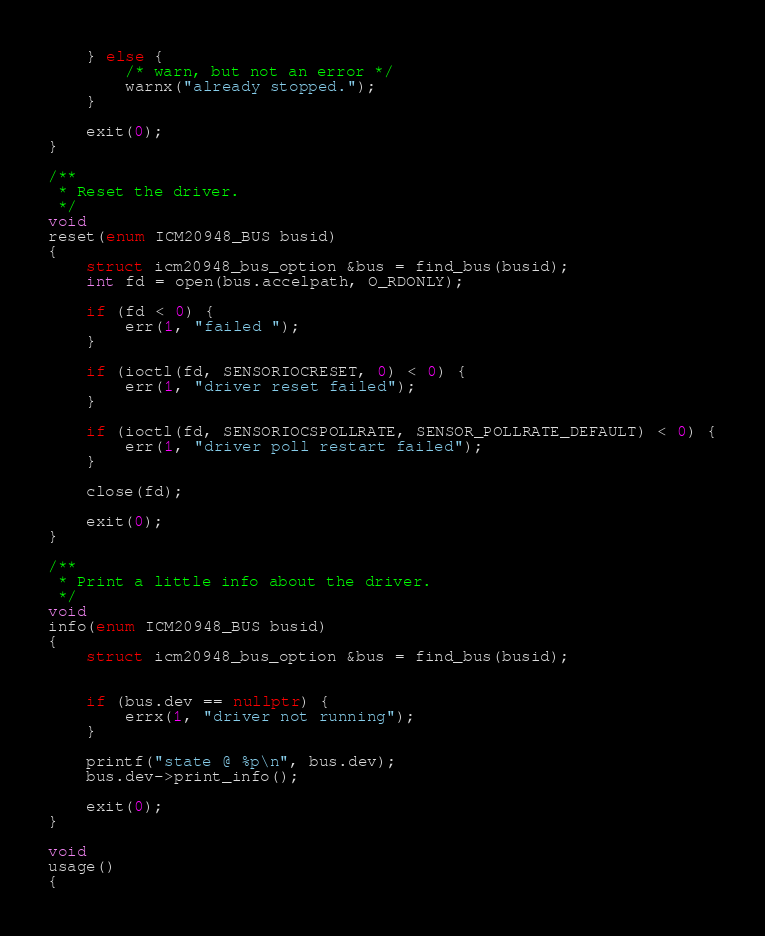<code> <loc_0><loc_0><loc_500><loc_500><_C++_>
	} else {
		/* warn, but not an error */
		warnx("already stopped.");
	}

	exit(0);
}

/**
 * Reset the driver.
 */
void
reset(enum ICM20948_BUS busid)
{
	struct icm20948_bus_option &bus = find_bus(busid);
	int fd = open(bus.accelpath, O_RDONLY);

	if (fd < 0) {
		err(1, "failed ");
	}

	if (ioctl(fd, SENSORIOCRESET, 0) < 0) {
		err(1, "driver reset failed");
	}

	if (ioctl(fd, SENSORIOCSPOLLRATE, SENSOR_POLLRATE_DEFAULT) < 0) {
		err(1, "driver poll restart failed");
	}

	close(fd);

	exit(0);
}

/**
 * Print a little info about the driver.
 */
void
info(enum ICM20948_BUS busid)
{
	struct icm20948_bus_option &bus = find_bus(busid);


	if (bus.dev == nullptr) {
		errx(1, "driver not running");
	}

	printf("state @ %p\n", bus.dev);
	bus.dev->print_info();

	exit(0);
}

void
usage()
{</code> 